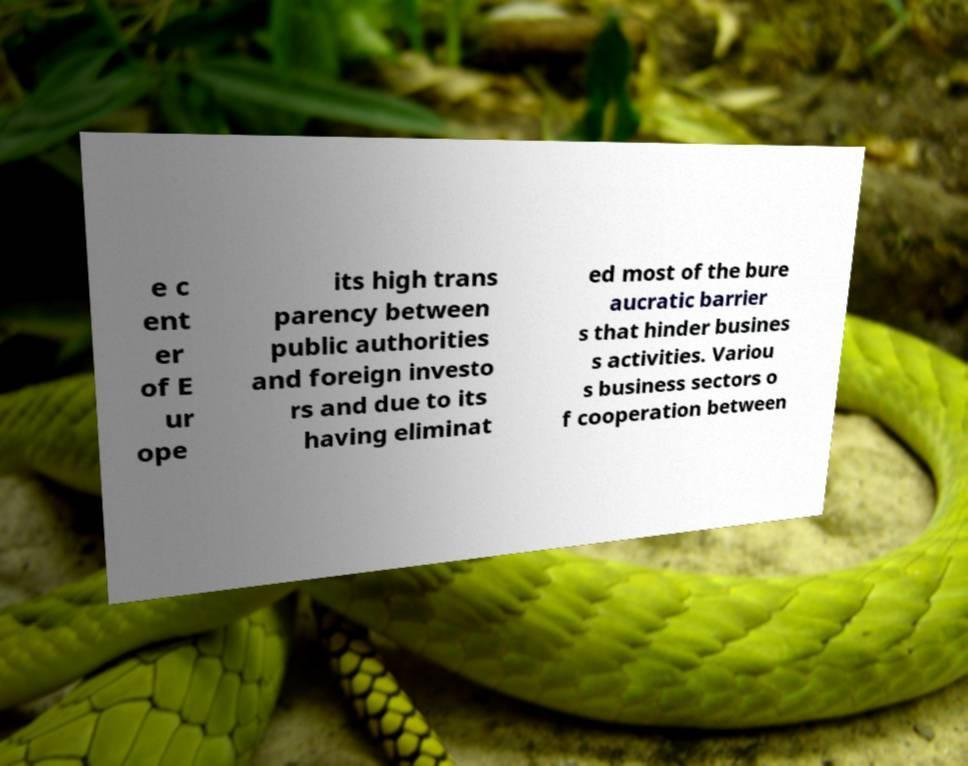Please read and relay the text visible in this image. What does it say? e c ent er of E ur ope its high trans parency between public authorities and foreign investo rs and due to its having eliminat ed most of the bure aucratic barrier s that hinder busines s activities. Variou s business sectors o f cooperation between 